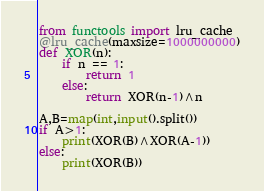Convert code to text. <code><loc_0><loc_0><loc_500><loc_500><_Python_>from functools import lru_cache
@lru_cache(maxsize=1000000000)
def XOR(n):
    if n == 1:
        return 1
    else:
        return XOR(n-1)^n
    
A,B=map(int,input().split())
if A>1:
    print(XOR(B)^XOR(A-1))
else:
    print(XOR(B))</code> 